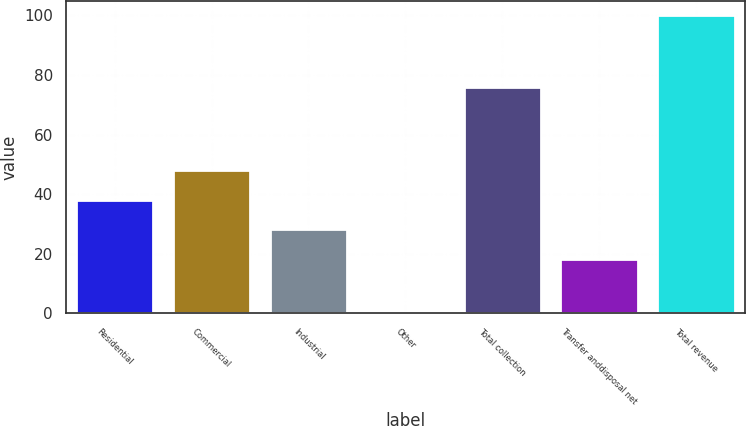<chart> <loc_0><loc_0><loc_500><loc_500><bar_chart><fcel>Residential<fcel>Commercial<fcel>Industrial<fcel>Other<fcel>Total collection<fcel>Transfer anddisposal net<fcel>Total revenue<nl><fcel>38.18<fcel>48.12<fcel>28.24<fcel>0.6<fcel>75.9<fcel>18.3<fcel>100<nl></chart> 